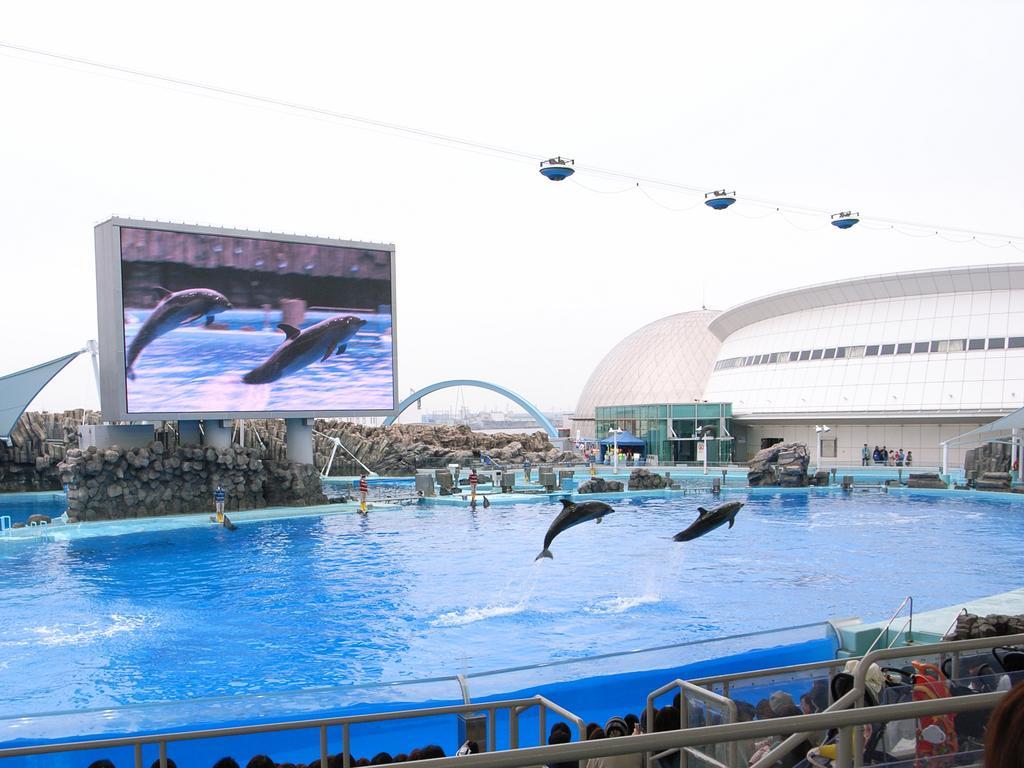Please provide a concise description of this image. In this picture we can see few metal rods, group of people, water and dolphins, in the background we can find few rocks, a screen, cables and buildings. 